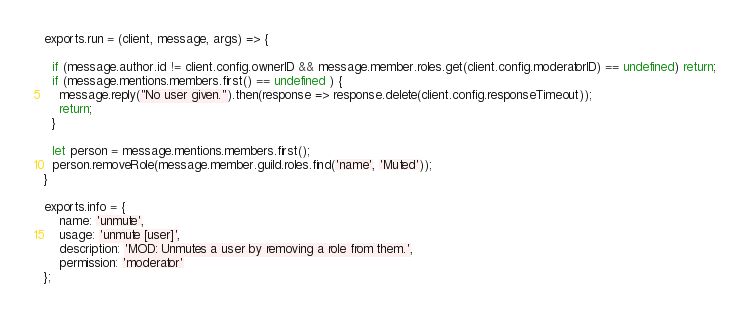<code> <loc_0><loc_0><loc_500><loc_500><_JavaScript_>exports.run = (client, message, args) => {

  if (message.author.id != client.config.ownerID && message.member.roles.get(client.config.moderatorID) == undefined) return;
  if (message.mentions.members.first() == undefined ) {
    message.reply("No user given.").then(response => response.delete(client.config.responseTimeout));
    return;
  }

  let person = message.mentions.members.first();
  person.removeRole(message.member.guild.roles.find('name', 'Muted'));
}

exports.info = {
    name: 'unmute',
    usage: 'unmute [user]',
    description: 'MOD: Unmutes a user by removing a role from them.',
    permission: 'moderator'
};
</code> 